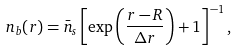Convert formula to latex. <formula><loc_0><loc_0><loc_500><loc_500>n _ { b } ( r ) = { \bar { n } _ { s } } \left [ \exp \left ( \frac { r - R } { \Delta r } \right ) + 1 \right ] ^ { - 1 } ,</formula> 